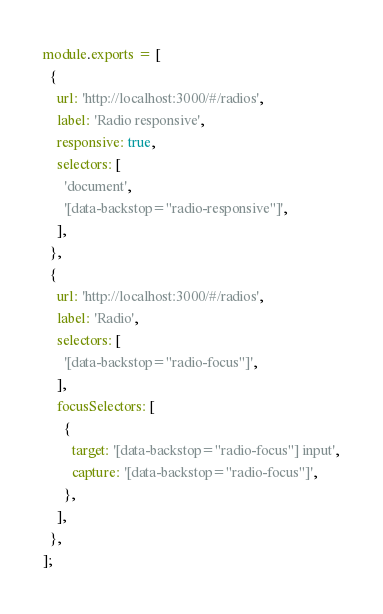<code> <loc_0><loc_0><loc_500><loc_500><_JavaScript_>module.exports = [
  {
    url: 'http://localhost:3000/#/radios',
    label: 'Radio responsive',
    responsive: true,
    selectors: [
      'document',
      '[data-backstop="radio-responsive"]',
    ],
  },
  {
    url: 'http://localhost:3000/#/radios',
    label: 'Radio',
    selectors: [
      '[data-backstop="radio-focus"]',
    ],
    focusSelectors: [
      {
        target: '[data-backstop="radio-focus"] input',
        capture: '[data-backstop="radio-focus"]',
      },
    ],
  },
];
</code> 